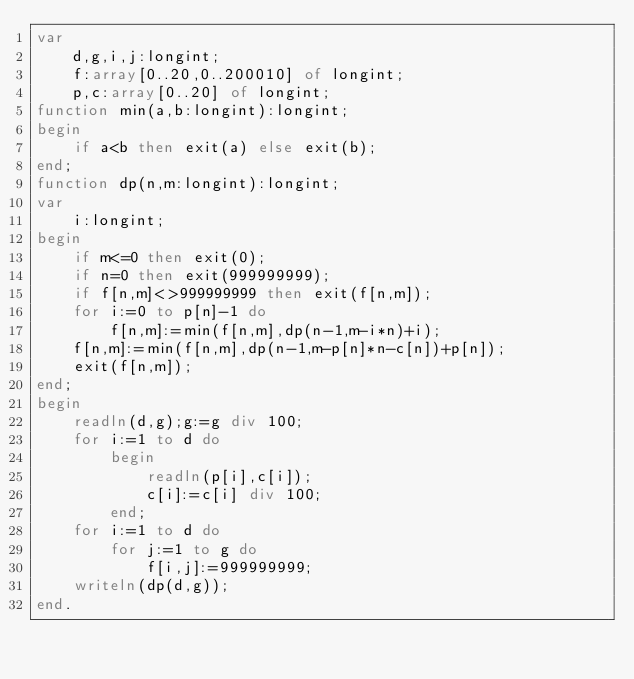<code> <loc_0><loc_0><loc_500><loc_500><_Pascal_>var
    d,g,i,j:longint;
    f:array[0..20,0..200010] of longint;
    p,c:array[0..20] of longint;
function min(a,b:longint):longint;
begin
    if a<b then exit(a) else exit(b);
end;
function dp(n,m:longint):longint;
var
    i:longint;
begin
    if m<=0 then exit(0);
    if n=0 then exit(999999999);
    if f[n,m]<>999999999 then exit(f[n,m]);
    for i:=0 to p[n]-1 do
        f[n,m]:=min(f[n,m],dp(n-1,m-i*n)+i);
    f[n,m]:=min(f[n,m],dp(n-1,m-p[n]*n-c[n])+p[n]);
    exit(f[n,m]);
end;
begin
    readln(d,g);g:=g div 100;
    for i:=1 to d do
        begin
            readln(p[i],c[i]);
            c[i]:=c[i] div 100;
        end;
    for i:=1 to d do
        for j:=1 to g do
            f[i,j]:=999999999;
    writeln(dp(d,g));
end.</code> 